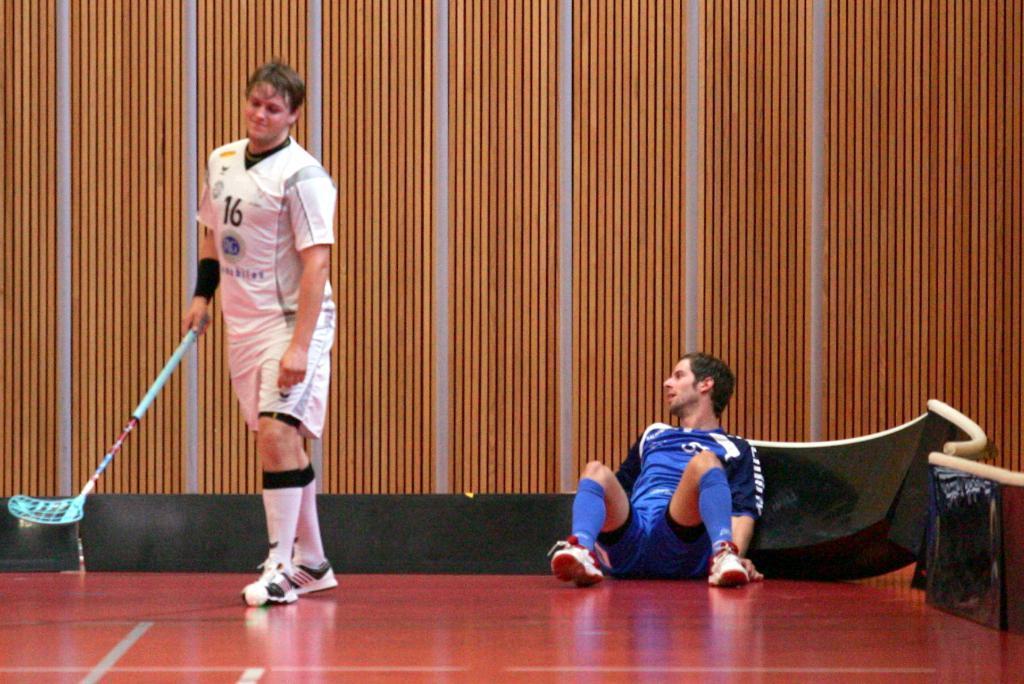Please provide a concise description of this image. In the background we can see the wall and objects. In this picture we can see a man sitting on the floor. On the left side of the picture we can see a man holding a stick. 